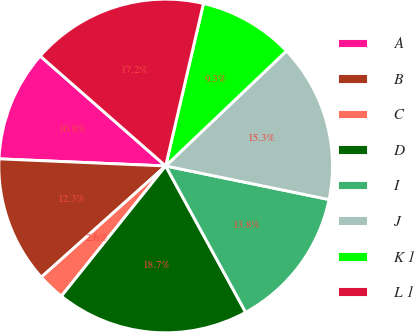Convert chart to OTSL. <chart><loc_0><loc_0><loc_500><loc_500><pie_chart><fcel>A<fcel>B<fcel>C<fcel>D<fcel>I<fcel>J<fcel>K 1<fcel>L 1<nl><fcel>10.77%<fcel>12.29%<fcel>2.64%<fcel>18.7%<fcel>13.81%<fcel>15.33%<fcel>9.25%<fcel>17.18%<nl></chart> 